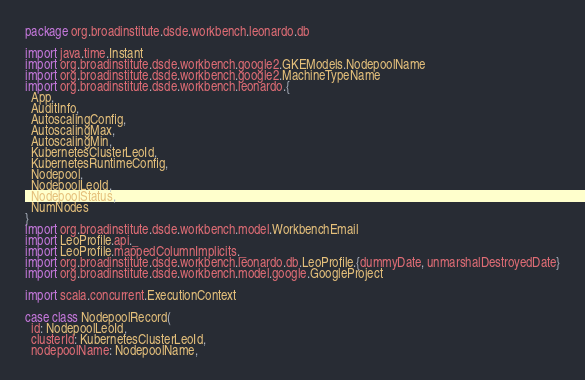Convert code to text. <code><loc_0><loc_0><loc_500><loc_500><_Scala_>package org.broadinstitute.dsde.workbench.leonardo.db

import java.time.Instant
import org.broadinstitute.dsde.workbench.google2.GKEModels.NodepoolName
import org.broadinstitute.dsde.workbench.google2.MachineTypeName
import org.broadinstitute.dsde.workbench.leonardo.{
  App,
  AuditInfo,
  AutoscalingConfig,
  AutoscalingMax,
  AutoscalingMin,
  KubernetesClusterLeoId,
  KubernetesRuntimeConfig,
  Nodepool,
  NodepoolLeoId,
  NodepoolStatus,
  NumNodes
}
import org.broadinstitute.dsde.workbench.model.WorkbenchEmail
import LeoProfile.api._
import LeoProfile.mappedColumnImplicits._
import org.broadinstitute.dsde.workbench.leonardo.db.LeoProfile.{dummyDate, unmarshalDestroyedDate}
import org.broadinstitute.dsde.workbench.model.google.GoogleProject

import scala.concurrent.ExecutionContext

case class NodepoolRecord(
  id: NodepoolLeoId,
  clusterId: KubernetesClusterLeoId,
  nodepoolName: NodepoolName,</code> 